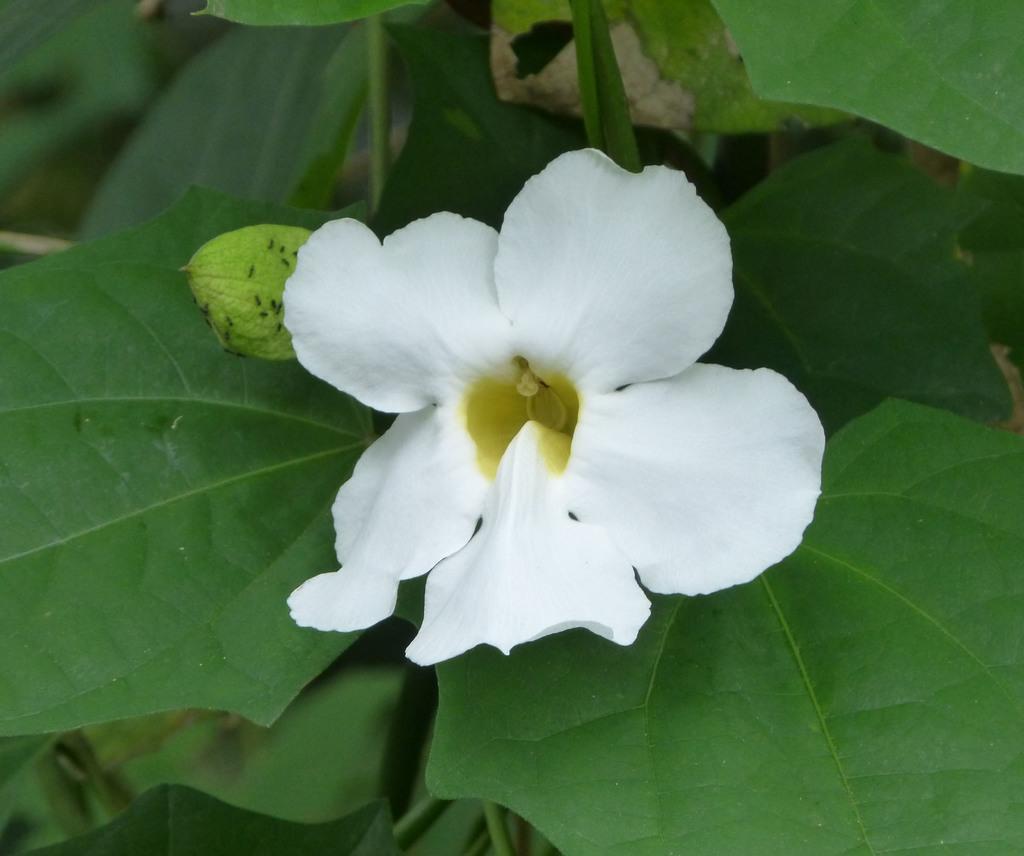Describe this image in one or two sentences. In this image I can see a plant along with a white color flower. I can see the leaves in green color. 